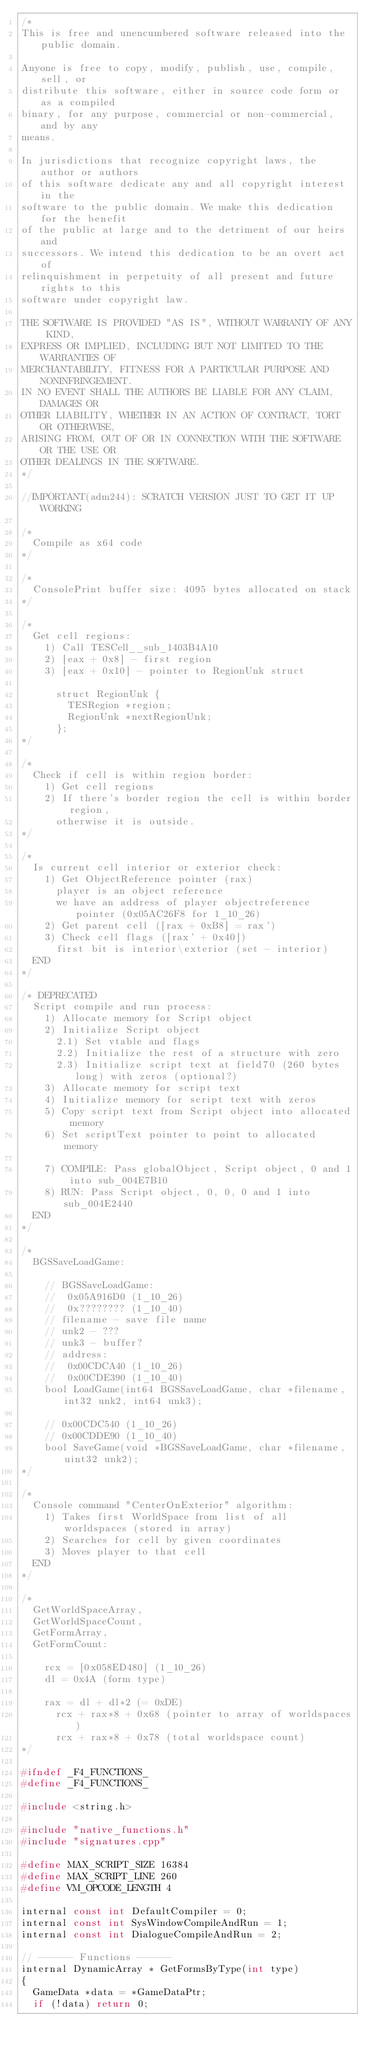Convert code to text. <code><loc_0><loc_0><loc_500><loc_500><_C++_>/*
This is free and unencumbered software released into the public domain.

Anyone is free to copy, modify, publish, use, compile, sell, or
distribute this software, either in source code form or as a compiled
binary, for any purpose, commercial or non-commercial, and by any
means.

In jurisdictions that recognize copyright laws, the author or authors
of this software dedicate any and all copyright interest in the
software to the public domain. We make this dedication for the benefit
of the public at large and to the detriment of our heirs and
successors. We intend this dedication to be an overt act of
relinquishment in perpetuity of all present and future rights to this
software under copyright law.

THE SOFTWARE IS PROVIDED "AS IS", WITHOUT WARRANTY OF ANY KIND,
EXPRESS OR IMPLIED, INCLUDING BUT NOT LIMITED TO THE WARRANTIES OF
MERCHANTABILITY, FITNESS FOR A PARTICULAR PURPOSE AND NONINFRINGEMENT.
IN NO EVENT SHALL THE AUTHORS BE LIABLE FOR ANY CLAIM, DAMAGES OR
OTHER LIABILITY, WHETHER IN AN ACTION OF CONTRACT, TORT OR OTHERWISE,
ARISING FROM, OUT OF OR IN CONNECTION WITH THE SOFTWARE OR THE USE OR
OTHER DEALINGS IN THE SOFTWARE.
*/

//IMPORTANT(adm244): SCRATCH VERSION JUST TO GET IT UP WORKING

/*
  Compile as x64 code
*/

/*
  ConsolePrint buffer size: 4095 bytes allocated on stack
*/

/*
  Get cell regions:
    1) Call TESCell__sub_1403B4A10
    2) [eax + 0x8] - first region
    3) [eax + 0x10] - pointer to RegionUnk struct
    
      struct RegionUnk {
        TESRegion *region;
        RegionUnk *nextRegionUnk;
      };
*/

/*
  Check if cell is within region border:
    1) Get cell regions
    2) If there's border region the cell is within border region,
      otherwise it is outside.
*/

/*
  Is current cell interior or exterior check:
    1) Get ObjectReference pointer (rax)
      player is an object reference
      we have an address of player objectreference pointer (0x05AC26F8 for 1_10_26)
    2) Get parent cell ([rax + 0xB8] = rax')
    3) Check cell flags ([rax' + 0x40])
      first bit is interior\exterior (set - interior)
  END
*/

/* DEPRECATED
  Script compile and run process:
    1) Allocate memory for Script object
    2) Initialize Script object
      2.1) Set vtable and flags
      2.2) Initialize the rest of a structure with zero
      2.3) Initialize script text at field70 (260 bytes long) with zeros (optional?)
    3) Allocate memory for script text
    4) Initialize memory for script text with zeros
    5) Copy script text from Script object into allocated memory
    6) Set scriptText pointer to point to allocated memory
    
    7) COMPILE: Pass globalObject, Script object, 0 and 1 into sub_004E7B10
    8) RUN: Pass Script object, 0, 0, 0 and 1 into sub_004E2440
  END
*/

/*
  BGSSaveLoadGame:
  
    // BGSSaveLoadGame:
    //  0x05A916D0 (1_10_26)
    //  0x???????? (1_10_40)
    // filename - save file name
    // unk2 - ???
    // unk3 - buffer?
    // address:
    //  0x00CDCA40 (1_10_26)
    //  0x00CDE390 (1_10_40)
    bool LoadGame(int64 BGSSaveLoadGame, char *filename, int32 unk2, int64 unk3);
    
    // 0x00CDC540 (1_10_26)
    // 0x00CDDE90 (1_10_40)
    bool SaveGame(void *BGSSaveLoadGame, char *filename, uint32 unk2);
*/

/*
  Console command "CenterOnExterior" algorithm:
    1) Takes first WorldSpace from list of all worldspaces (stored in array)
    2) Searches for cell by given coordinates
    3) Moves player to that cell
  END
*/

/*
  GetWorldSpaceArray,
  GetWorldSpaceCount,
  GetFormArray,
  GetFormCount:
  
    rcx = [0x058ED480] (1_10_26)
    dl = 0x4A (form type)
    
    rax = dl + dl*2 (= 0xDE)
      rcx + rax*8 + 0x68 (pointer to array of worldspaces)
      rcx + rax*8 + 0x78 (total worldspace count)  
*/

#ifndef _F4_FUNCTIONS_
#define _F4_FUNCTIONS_

#include <string.h>

#include "native_functions.h"
#include "signatures.cpp"

#define MAX_SCRIPT_SIZE 16384
#define MAX_SCRIPT_LINE 260
#define VM_OPCODE_LENGTH 4

internal const int DefaultCompiler = 0;
internal const int SysWindowCompileAndRun = 1;
internal const int DialogueCompileAndRun = 2;

// ------ Functions ------
internal DynamicArray * GetFormsByType(int type)
{
  GameData *data = *GameDataPtr;
  if (!data) return 0;</code> 